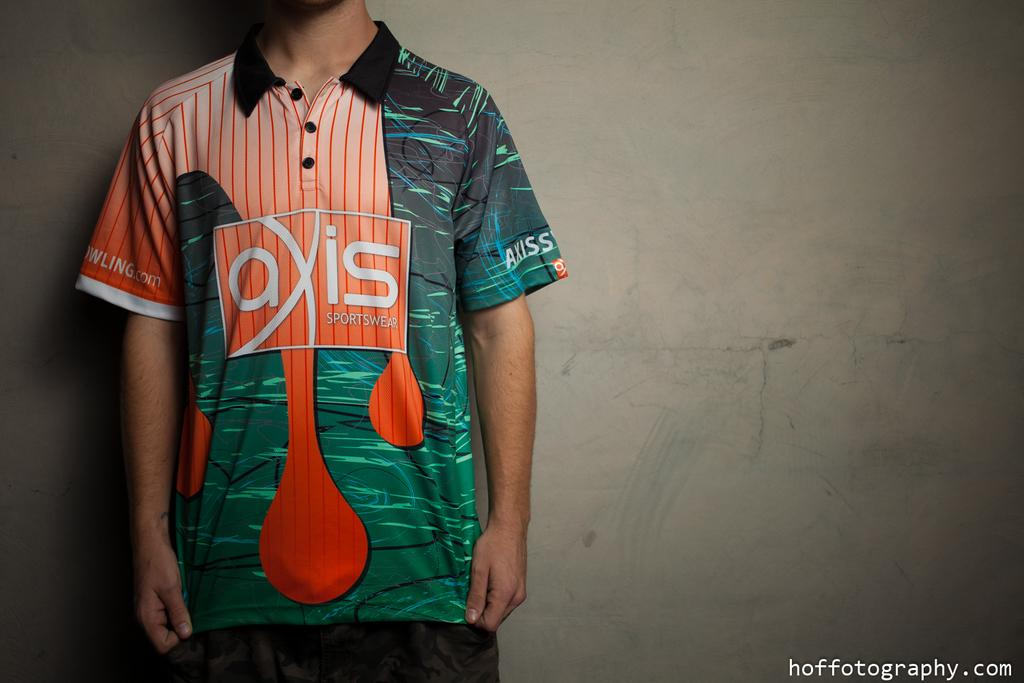<image>
Share a concise interpretation of the image provided. Model posing in front of a white wall sponsored by AXIS sportswear. 